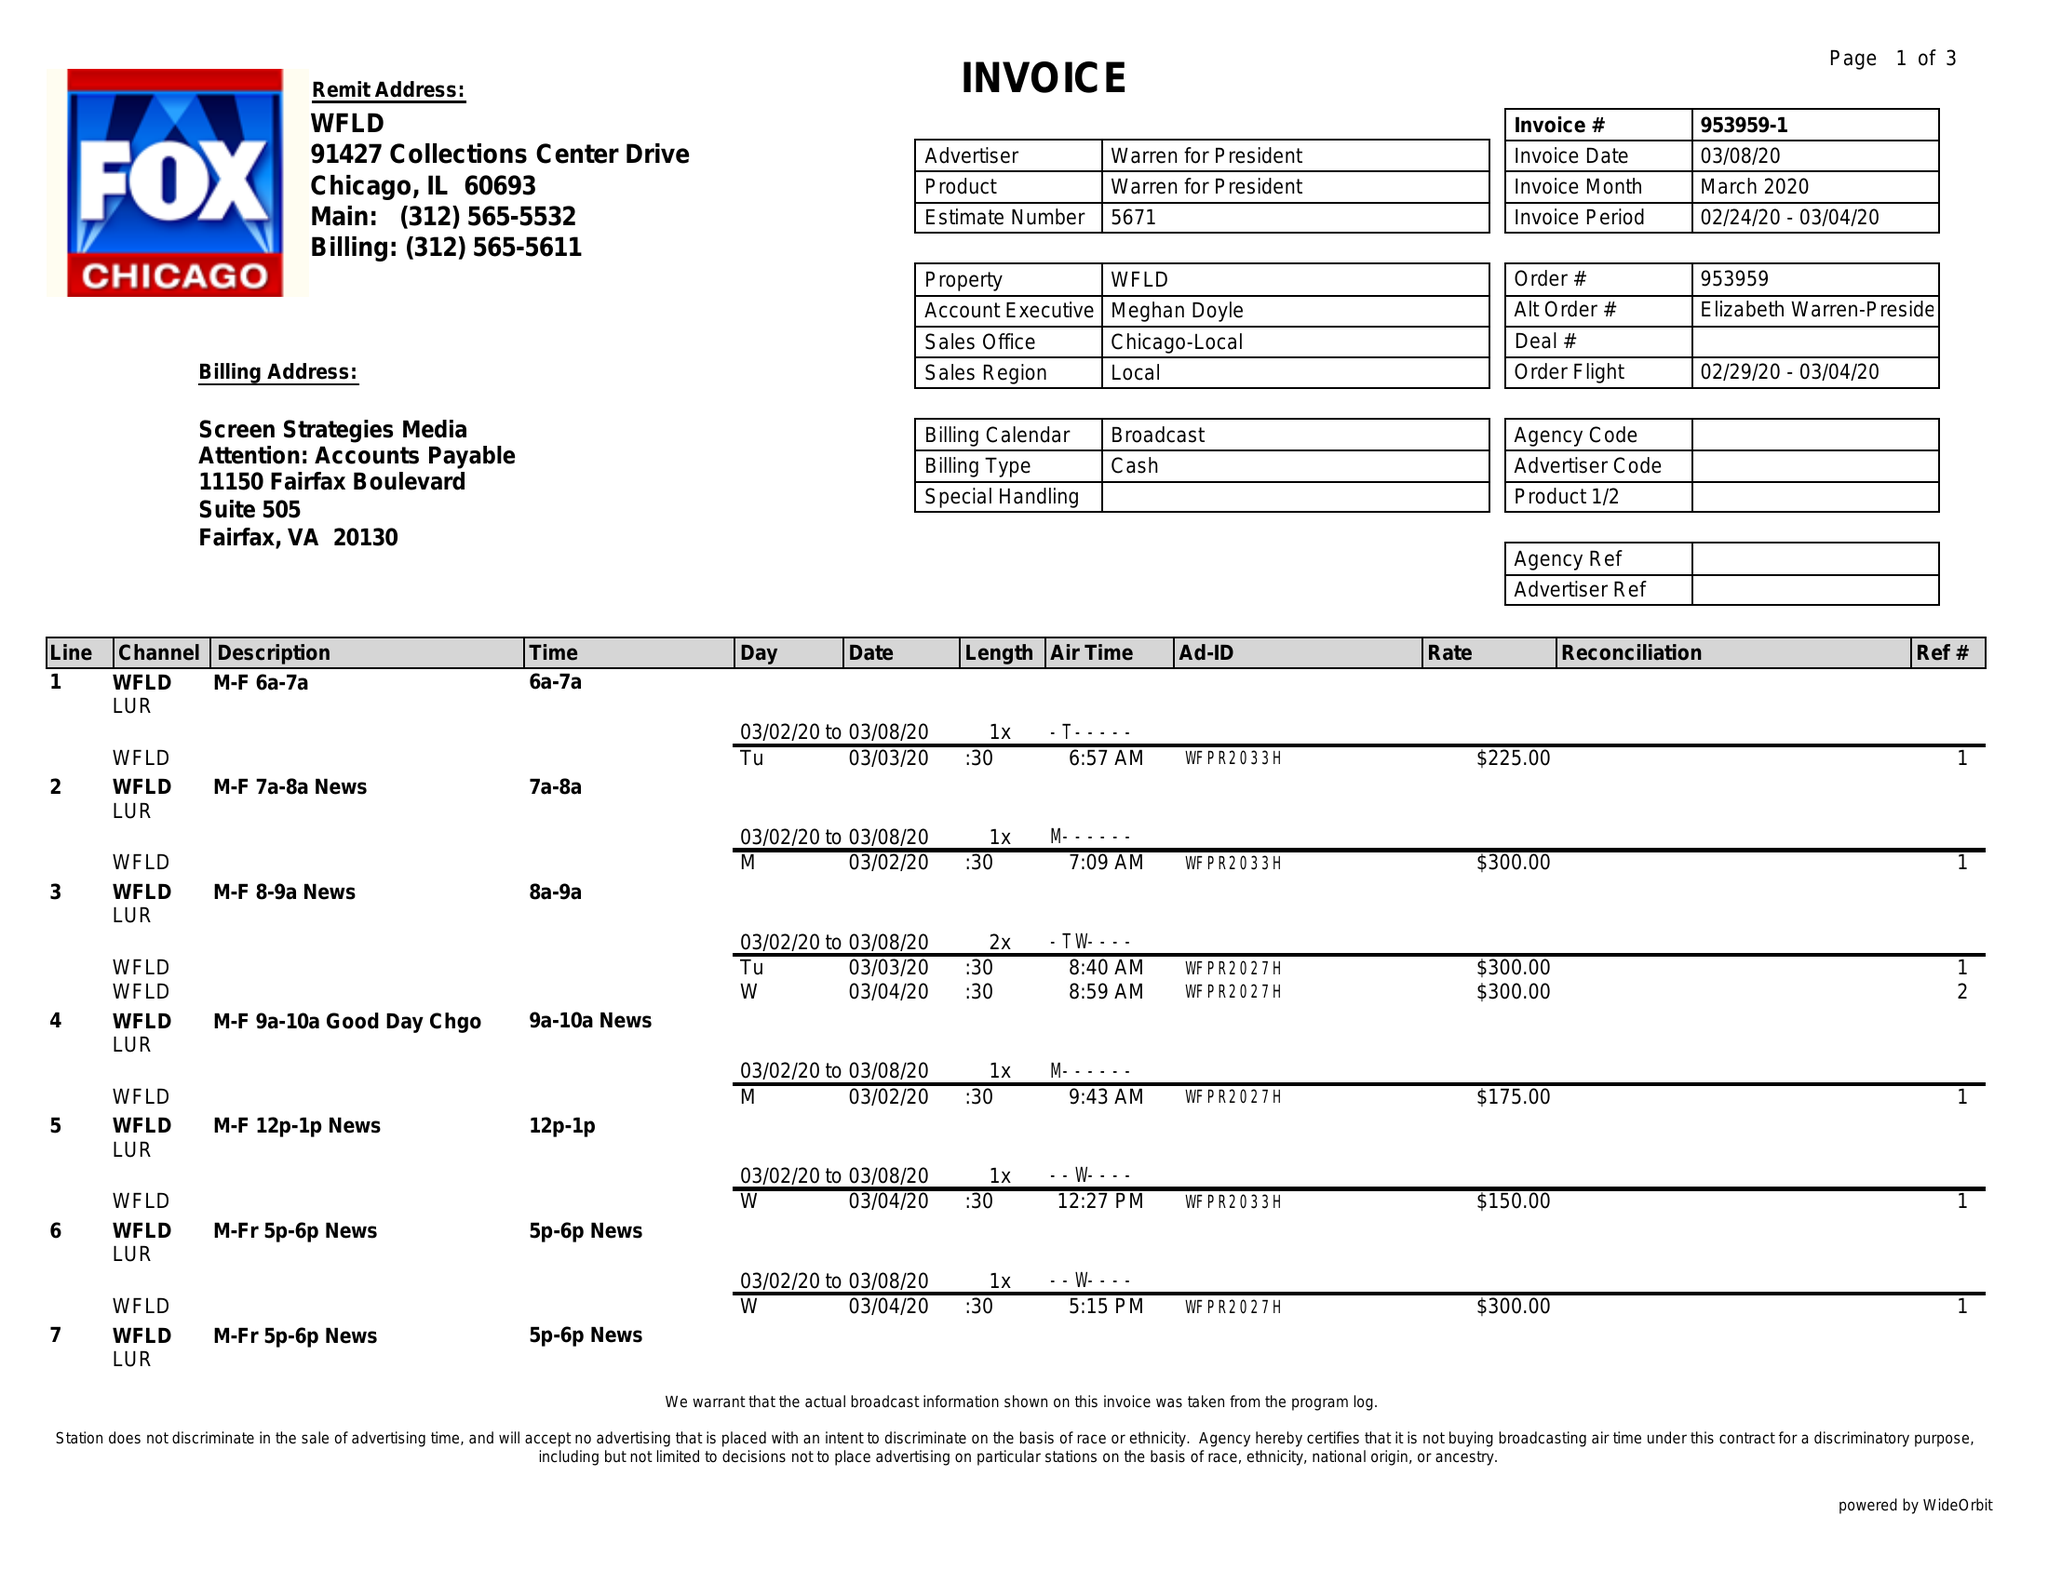What is the value for the flight_to?
Answer the question using a single word or phrase. 03/04/20 